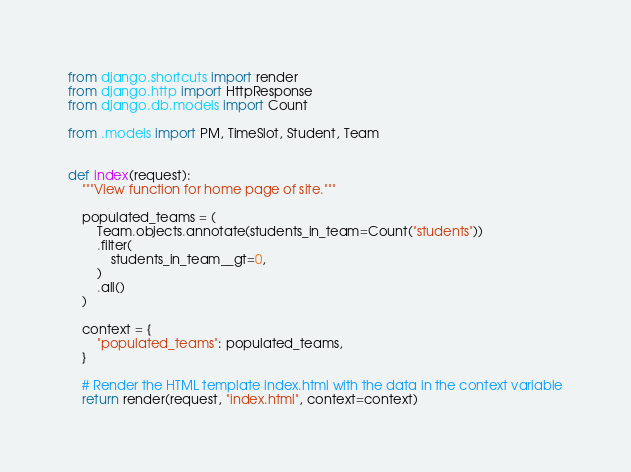<code> <loc_0><loc_0><loc_500><loc_500><_Python_>from django.shortcuts import render
from django.http import HttpResponse
from django.db.models import Count

from .models import PM, TimeSlot, Student, Team


def index(request):
    """View function for home page of site."""

    populated_teams = (
        Team.objects.annotate(students_in_team=Count("students"))
        .filter(
            students_in_team__gt=0,
        )
        .all()
    )

    context = {
        "populated_teams": populated_teams,
    }

    # Render the HTML template index.html with the data in the context variable
    return render(request, "index.html", context=context)
</code> 